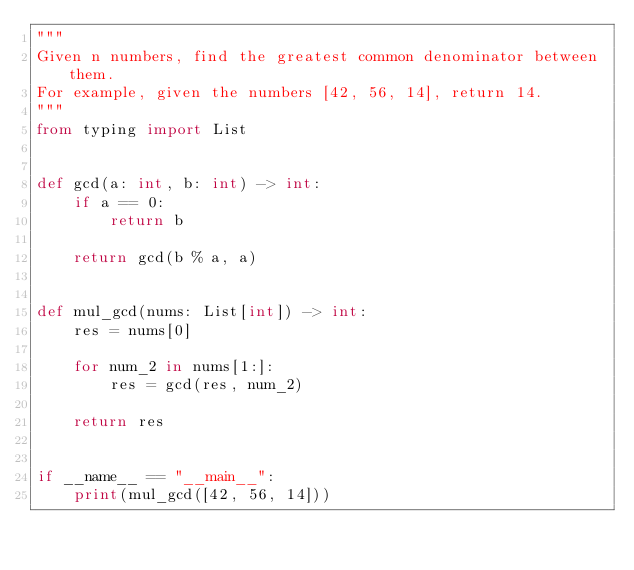<code> <loc_0><loc_0><loc_500><loc_500><_Python_>"""
Given n numbers, find the greatest common denominator between them.
For example, given the numbers [42, 56, 14], return 14.
"""
from typing import List


def gcd(a: int, b: int) -> int:
    if a == 0:
        return b

    return gcd(b % a, a)


def mul_gcd(nums: List[int]) -> int:
    res = nums[0]

    for num_2 in nums[1:]:
        res = gcd(res, num_2)

    return res


if __name__ == "__main__":
    print(mul_gcd([42, 56, 14]))
</code> 